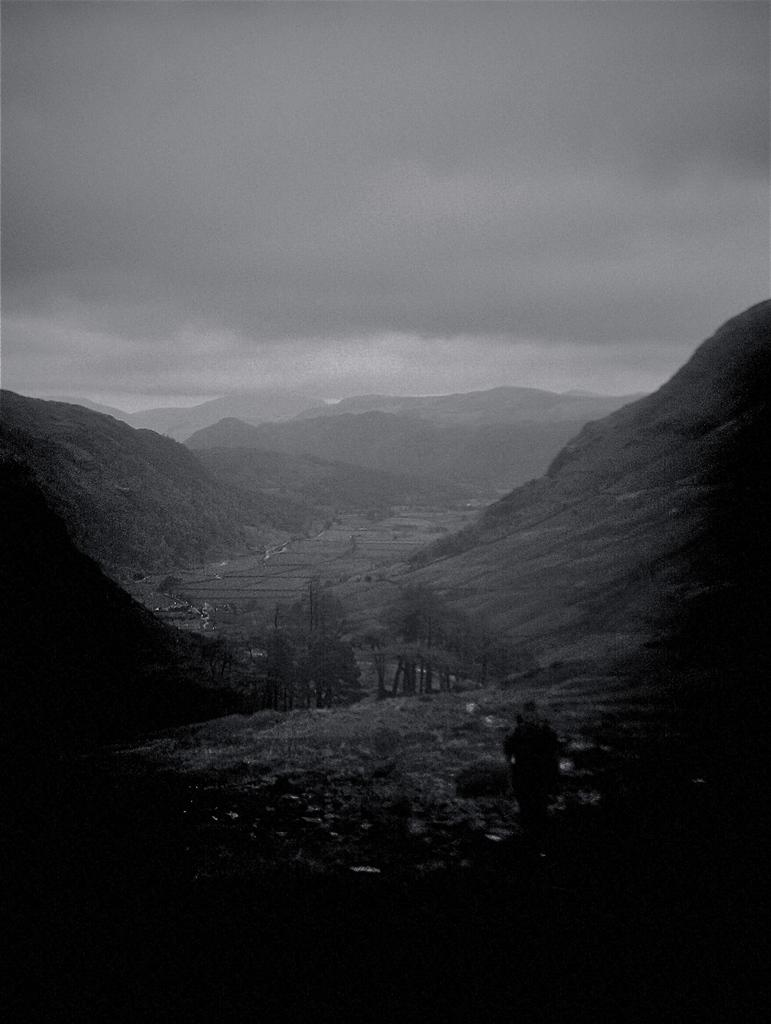What type of landscape is depicted in the image? The image features hills on either side. What can be seen on the hills? The hills have plants and trees on them. What is visible in the background of the image? The sky is visible in the image. What is the condition of the sky in the image? Clouds are present in the sky. Can you tell me how many planes are flying in the scene? There are no planes present in the image; it features hills with plants and trees, and a sky with clouds. What type of pocket can be seen in the scene? There is no pocket present in the scene; it is a landscape image with hills, plants, trees, sky, and clouds. 